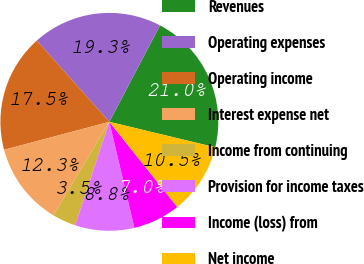Convert chart. <chart><loc_0><loc_0><loc_500><loc_500><pie_chart><fcel>Revenues<fcel>Operating expenses<fcel>Operating income<fcel>Interest expense net<fcel>Income from continuing<fcel>Provision for income taxes<fcel>Income (loss) from<fcel>Net income<nl><fcel>21.05%<fcel>19.3%<fcel>17.54%<fcel>12.28%<fcel>3.51%<fcel>8.77%<fcel>7.02%<fcel>10.53%<nl></chart> 